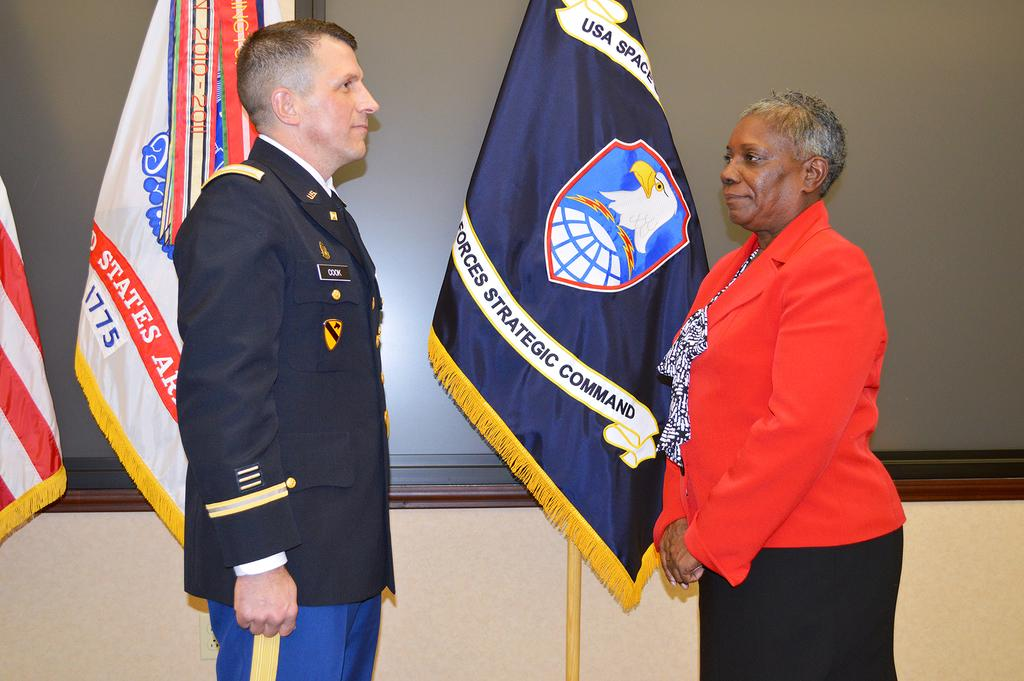Provide a one-sentence caption for the provided image. a man in uniform with the name Cook standing in front of flags and woman in red. 